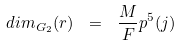Convert formula to latex. <formula><loc_0><loc_0><loc_500><loc_500>d i m _ { G _ { 2 } } ( r ) \ = \ \frac { M } { F } p ^ { 5 } ( j ) \</formula> 